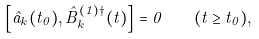Convert formula to latex. <formula><loc_0><loc_0><loc_500><loc_500>\left [ \hat { a } _ { k } ( t _ { 0 } ) , \hat { B } _ { k } ^ { ( 1 ) \dagger } ( t ) \right ] = 0 \quad ( t \geq t _ { 0 } ) ,</formula> 